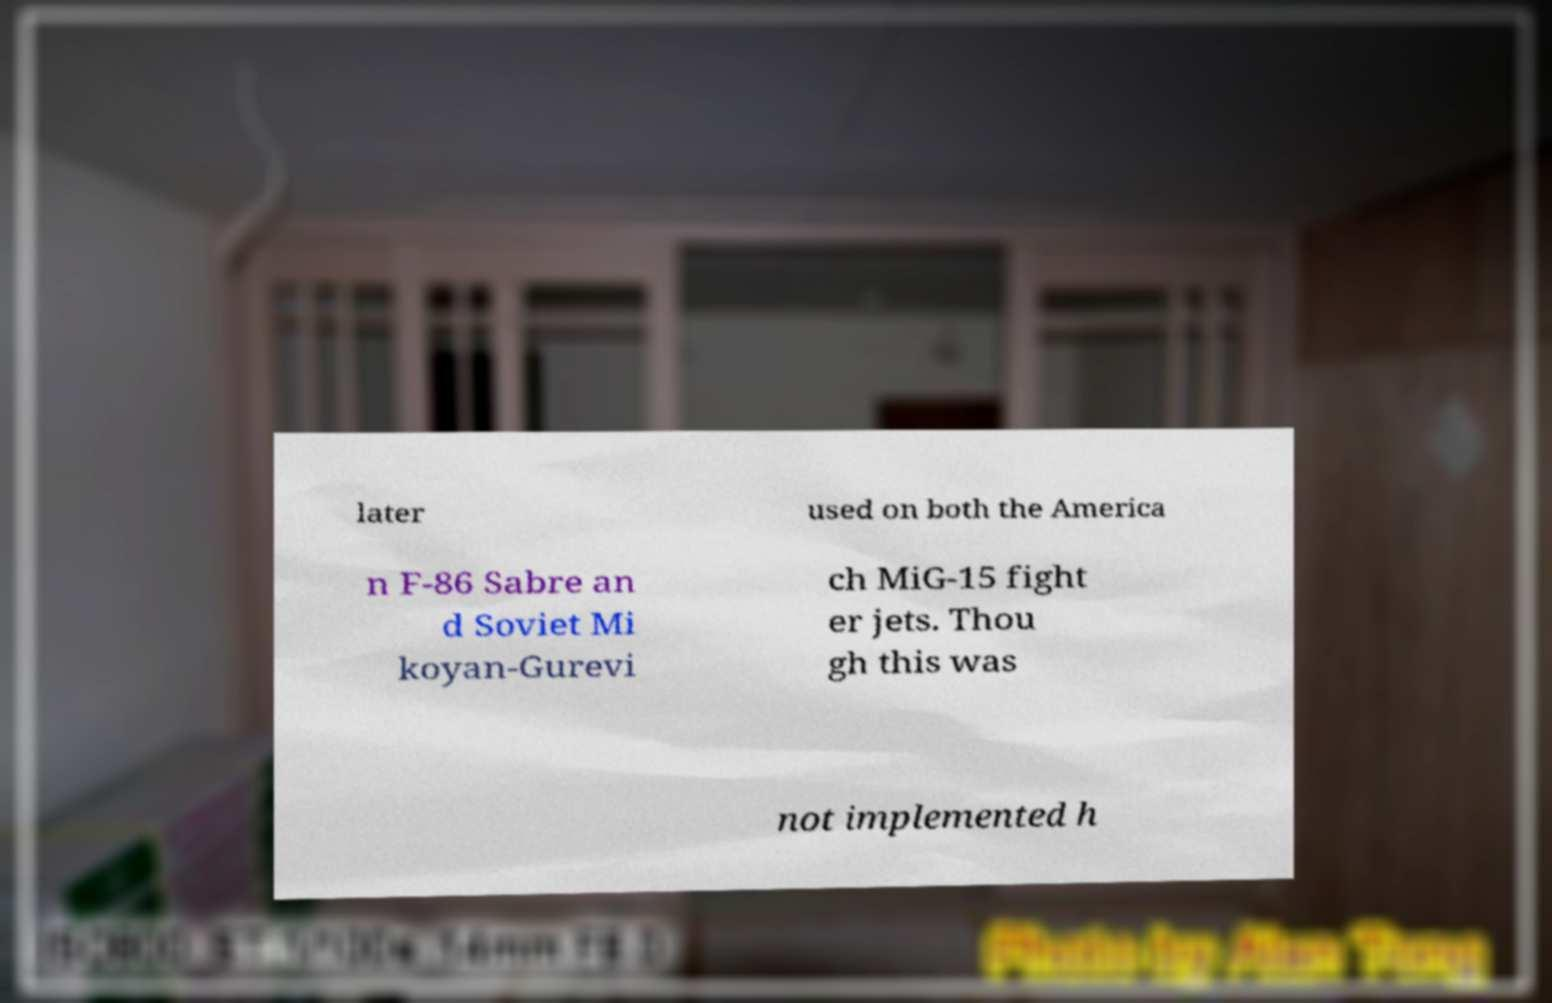I need the written content from this picture converted into text. Can you do that? later used on both the America n F-86 Sabre an d Soviet Mi koyan-Gurevi ch MiG-15 fight er jets. Thou gh this was not implemented h 